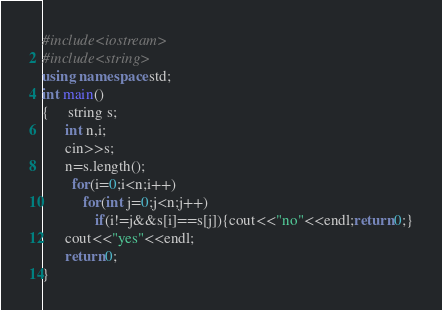<code> <loc_0><loc_0><loc_500><loc_500><_C++_>#include<iostream>
#include<string>
using namespace std;
int main()
{     string s;
      int n,i;
      cin>>s;
      n=s.length();
        for(i=0;i<n;i++)
           for(int j=0;j<n;j++)
              if(i!=j&&s[i]==s[j]){cout<<"no"<<endl;return 0;}
      cout<<"yes"<<endl;
	  return 0;
}
</code> 